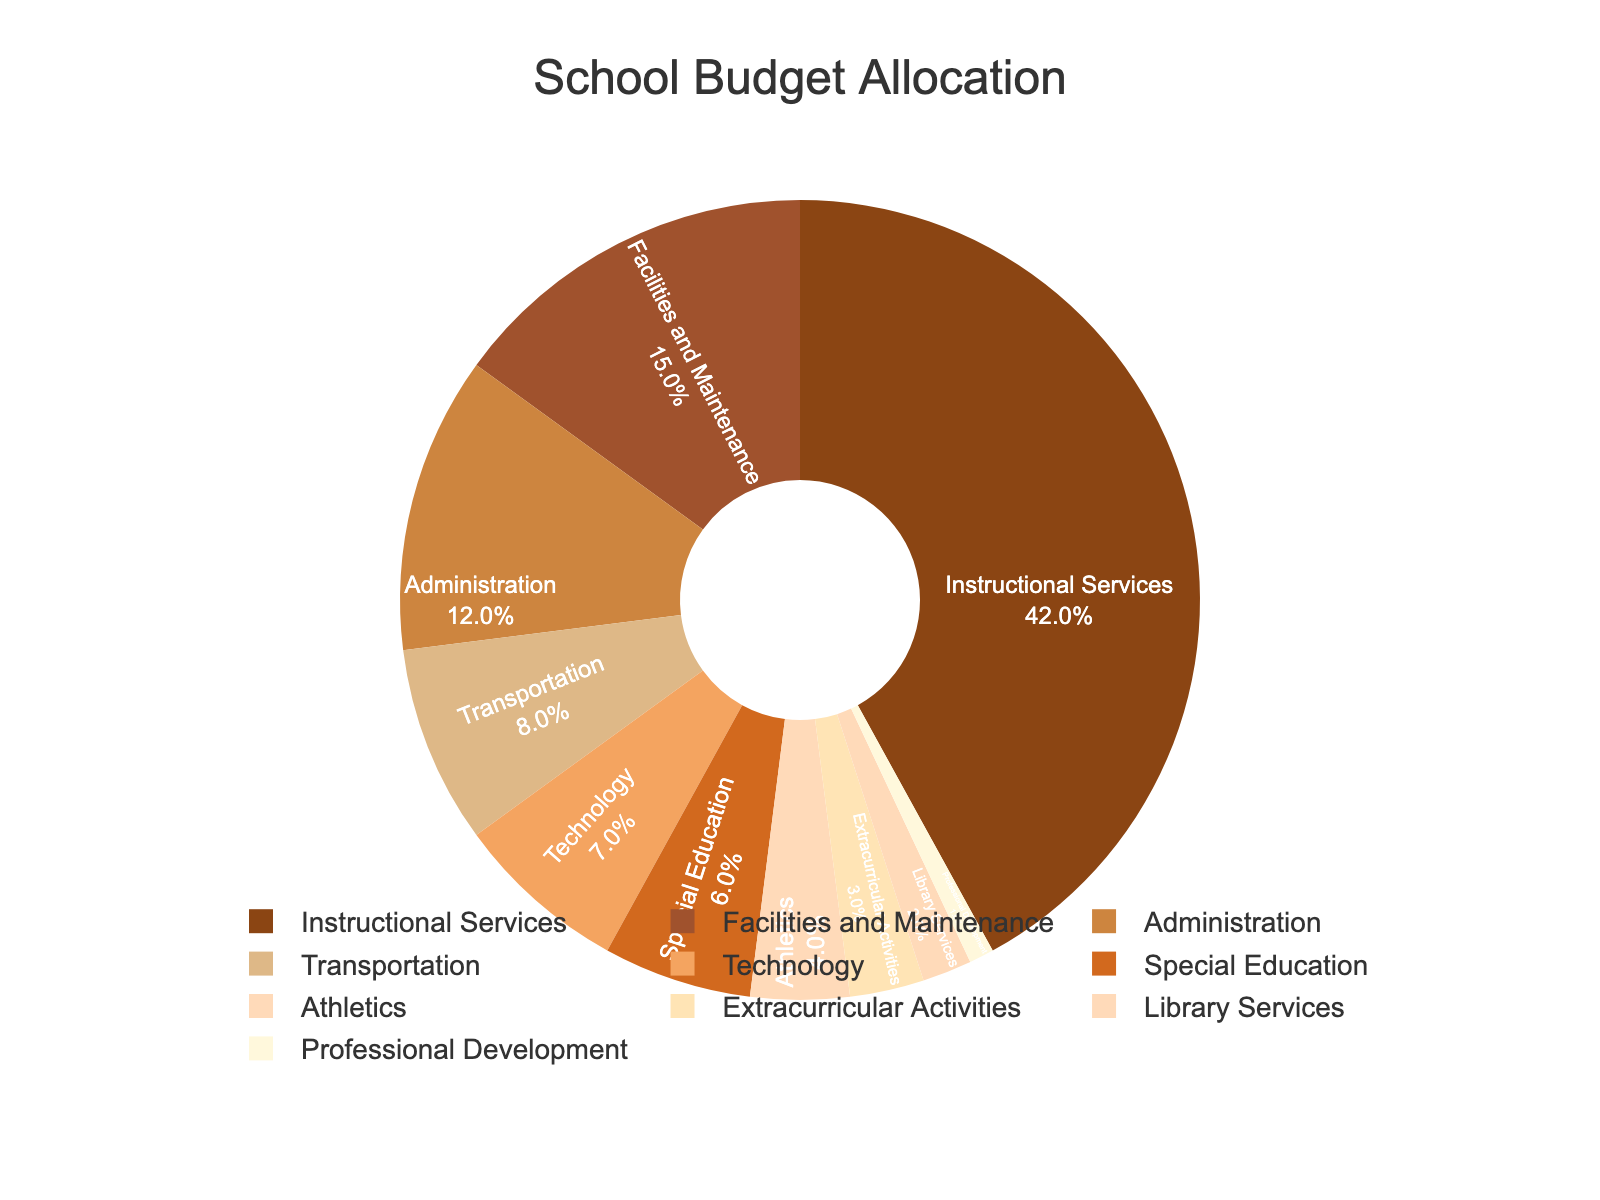Which department receives the highest percentage of the budget? The department with the highest percentage of the budget is listed at 42%. This is the largest segment of the pie chart.
Answer: Instructional Services Which department receives the lowest percentage of the budget? The department with the lowest percentage of the budget is the one with 1%, represented by the smallest segment in the pie chart.
Answer: Professional Development What is the combined budget percentage for Athletics and Extracurricular Activities? Athletics and Extracurricular Activities receive 4% and 3% of the budget respectively. Summing these gives 4% + 3% = 7%.
Answer: 7% Does the budget allocated to Technology exceed that allocated to Transportation? Technology is allocated 7% of the budget while Transportation gets 8%. Therefore, Technology does not exceed Transportation.
Answer: No How much more budget percentage is allocated to Facilities and Maintenance than to Special Education? Facilities and Maintenance receive 15% of the budget and Special Education gets 6%. The difference is 15% - 6% = 9%.
Answer: 9% Which departments receive a budget allocation greater than 10%? The pie chart shows that Instructional Services (42%), Facilities and Maintenance (15%), and Administration (12%) each receive more than 10% of the budget.
Answer: Instructional Services, Facilities and Maintenance, Administration What is the median budget percentage among the departments? To find the median, list the percentages in order: 1, 2, 3, 4, 6, 7, 8, 12, 15, 42. The median is the average of the 5th and 6th percentages: (6 + 7) / 2 = 6.5%.
Answer: 6.5% Which department receives the fourth largest portion of the budget? The pie chart shows that the largest to smallest portions are: Instructional Services (42%), Facilities and Maintenance (15%), Administration (12%), and Transportation (8%).
Answer: Transportation Is the combined budget percentage for Library Services and Professional Development greater than that for Athletics? Library Services and Professional Development combined equal 2% + 1% = 3%, which is equal to the 3% allocated to Athletics.
Answer: No What percentage of the budget is allocated to departments other than Instructional Services and Facilities and Maintenance? Summing the percentages of all departments except Instructional Services and Facilities and Maintenance: 12 + 8 + 7 + 6 + 4 + 3 + 2 + 1 = 43%.
Answer: 43% 